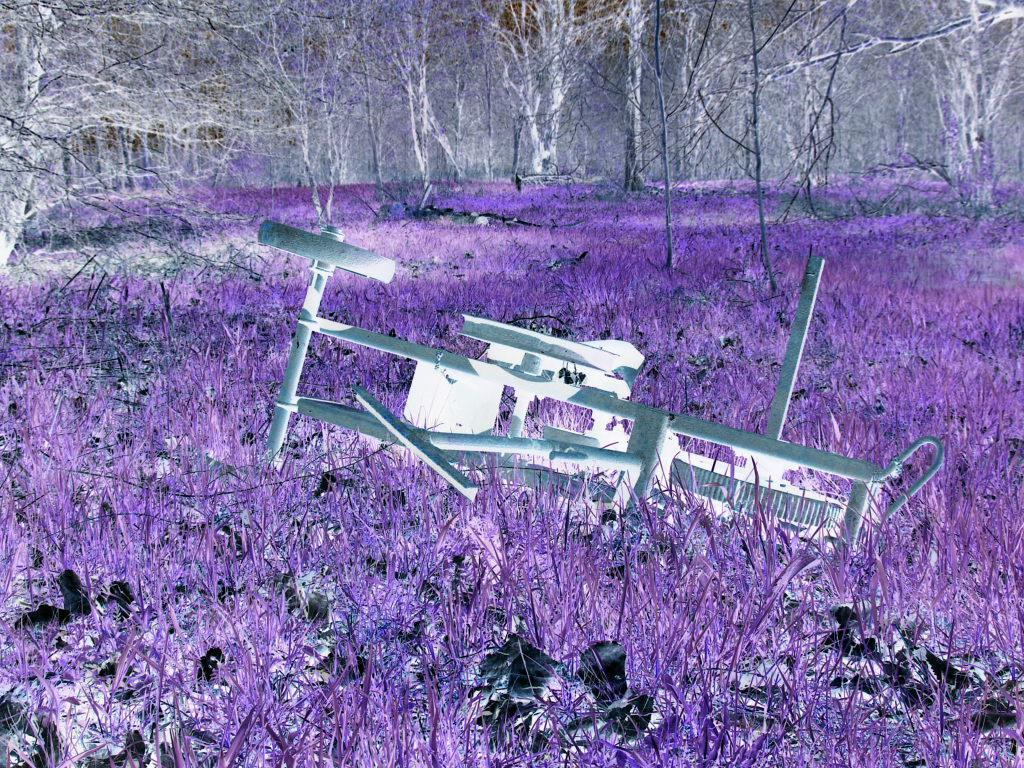What is the main subject in the image? There is an object in the image. What type of living organisms can be seen in the image? Plants are visible in the image. What can be seen in the background of the image? There are trees in the background of the image. Where is the stove located in the image? There is no stove present in the image. What type of lamp can be seen hanging from the tree in the image? There is no lamp present in the image, and no tree is mentioned in the provided facts. 